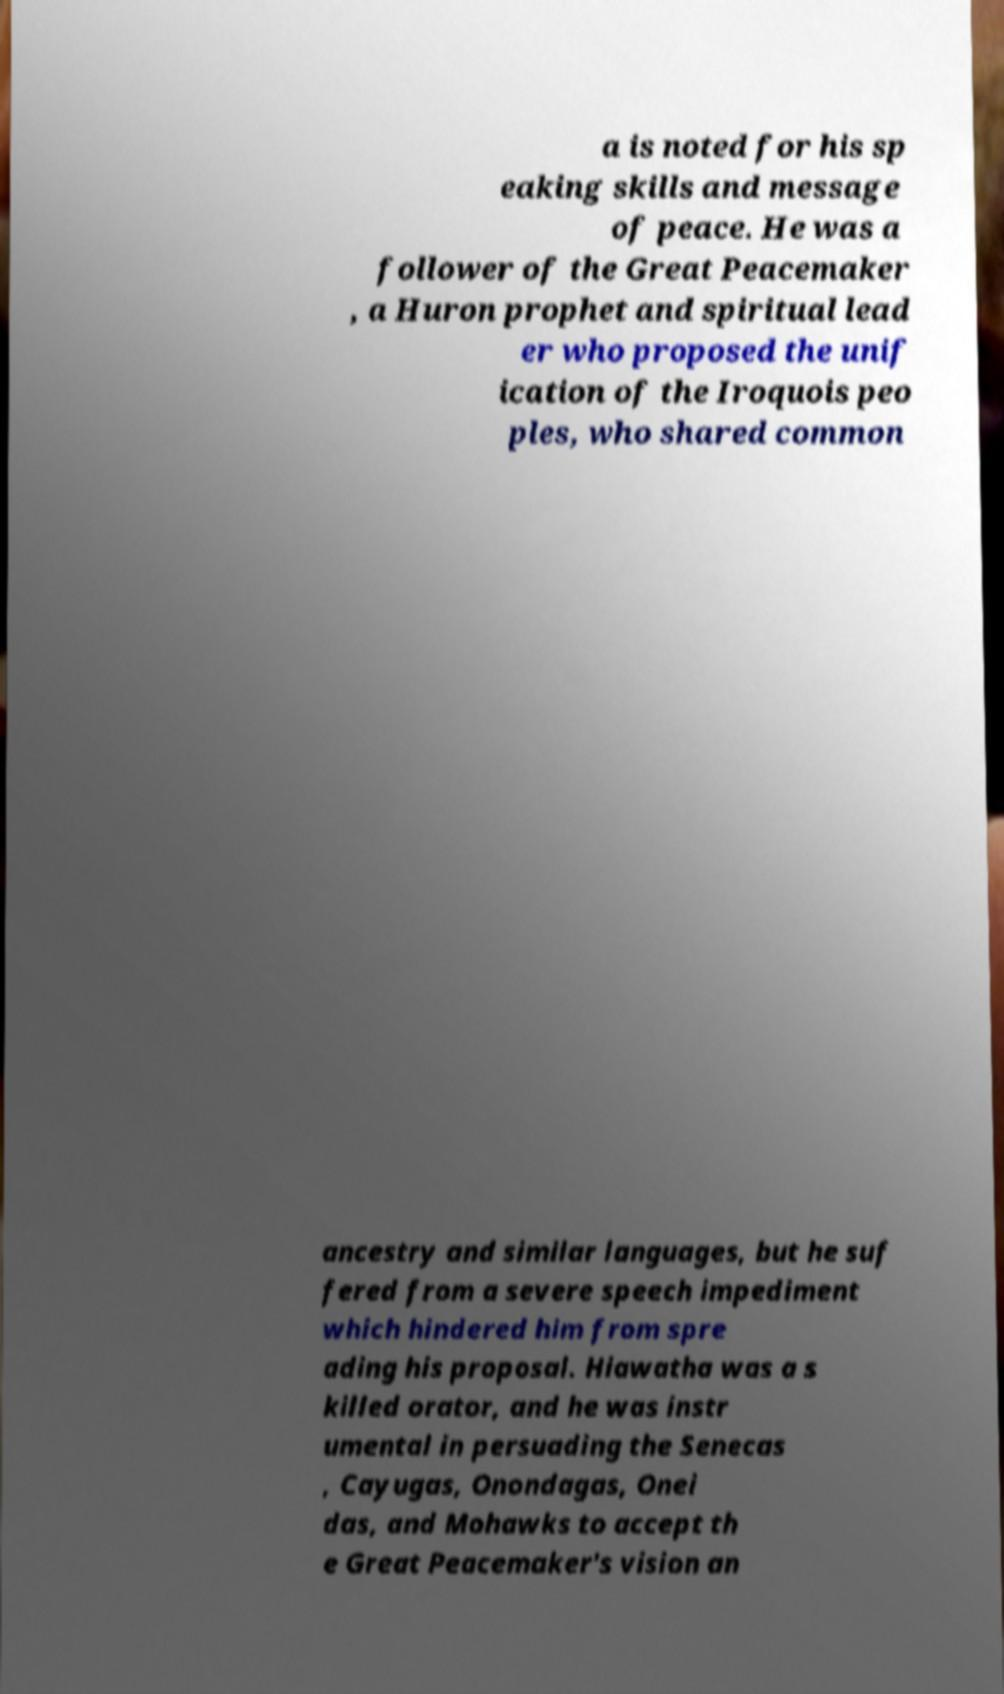What messages or text are displayed in this image? I need them in a readable, typed format. a is noted for his sp eaking skills and message of peace. He was a follower of the Great Peacemaker , a Huron prophet and spiritual lead er who proposed the unif ication of the Iroquois peo ples, who shared common ancestry and similar languages, but he suf fered from a severe speech impediment which hindered him from spre ading his proposal. Hiawatha was a s killed orator, and he was instr umental in persuading the Senecas , Cayugas, Onondagas, Onei das, and Mohawks to accept th e Great Peacemaker's vision an 